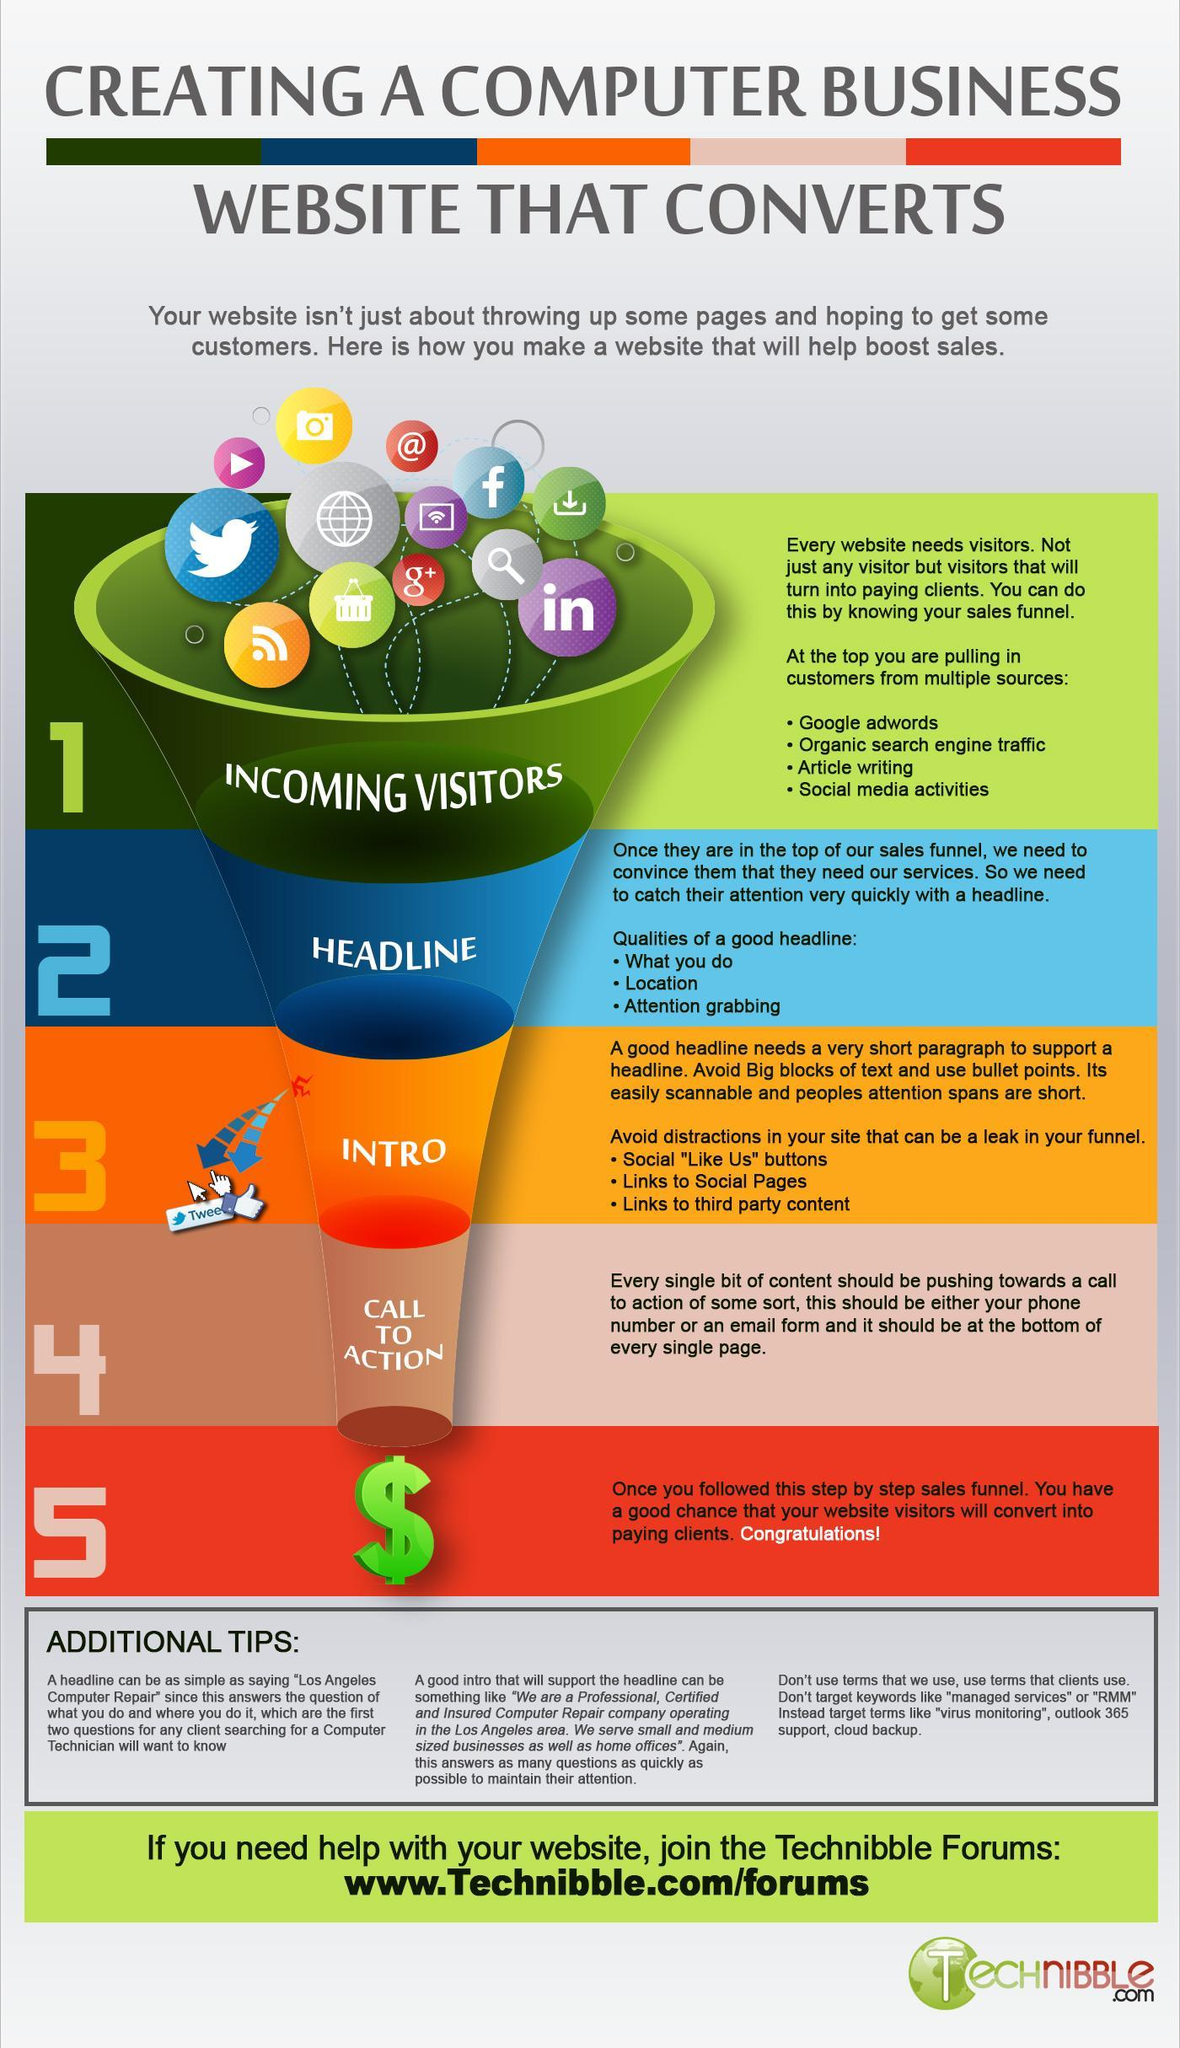What is the third point of the qualities of a good headline?
Answer the question with a short phrase. Attention grabbing How many download icons are in this infographic? 1 What is the second point of the qualities of a good headline? Location What is the color of the dollar sign-orange, green, blue, or red? green How many search icons are in this infographic? 1 How many social media icons are in this infographic? 4 What is the total number of icons in this infographic? 13 